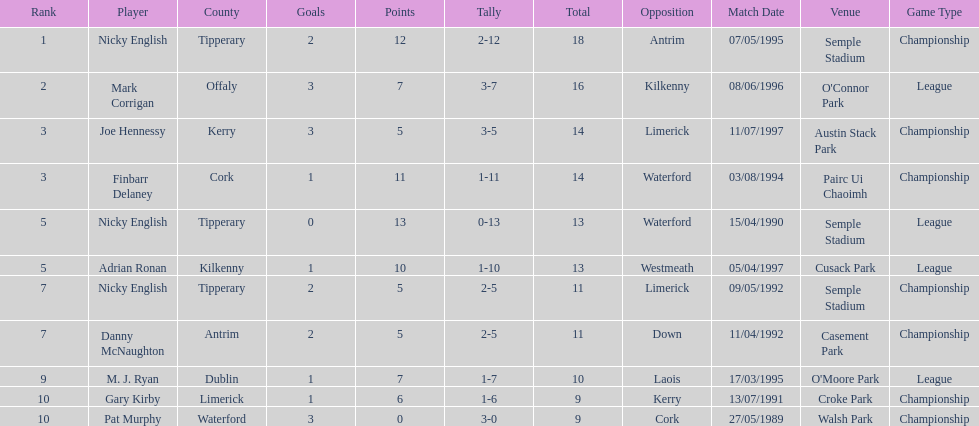How many times was waterford the opposition? 2. 